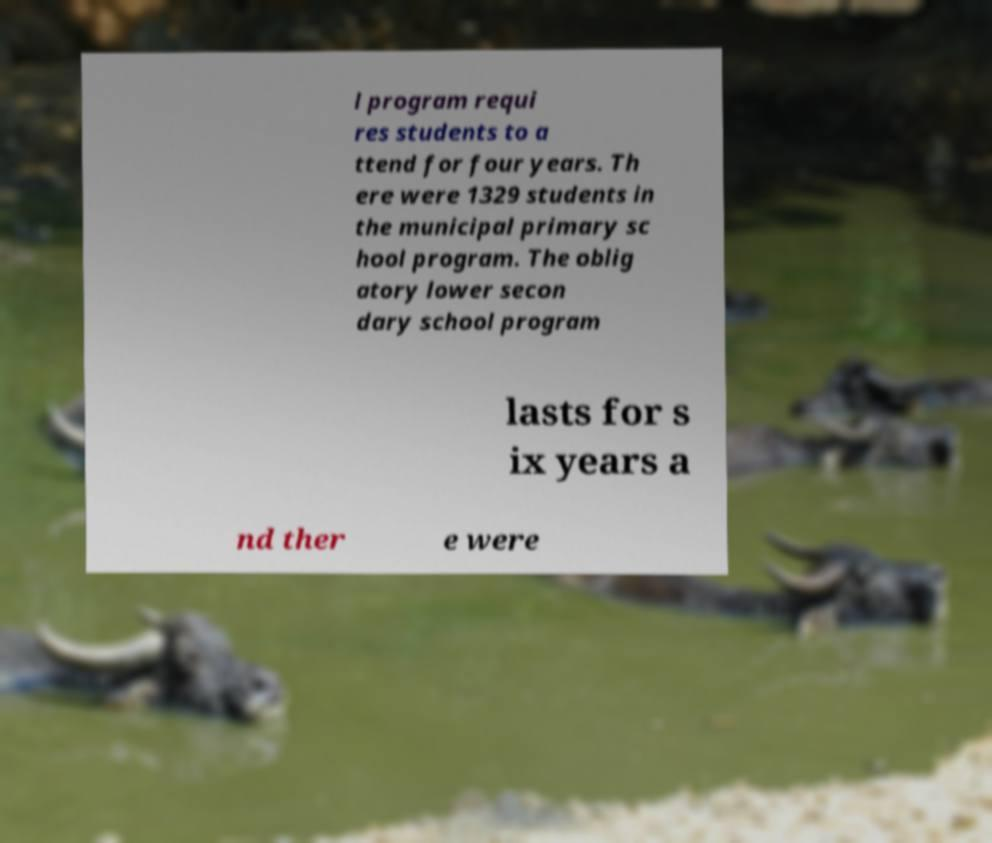Please read and relay the text visible in this image. What does it say? l program requi res students to a ttend for four years. Th ere were 1329 students in the municipal primary sc hool program. The oblig atory lower secon dary school program lasts for s ix years a nd ther e were 